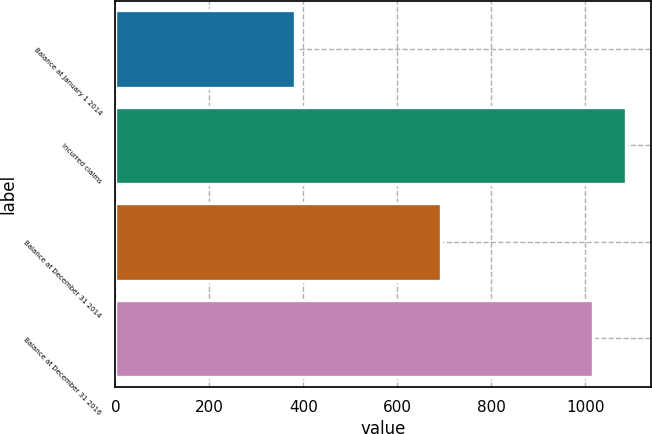<chart> <loc_0><loc_0><loc_500><loc_500><bar_chart><fcel>Balance at January 1 2014<fcel>Incurred claims<fcel>Balance at December 31 2014<fcel>Balance at December 31 2016<nl><fcel>383<fcel>1086.3<fcel>693<fcel>1017<nl></chart> 